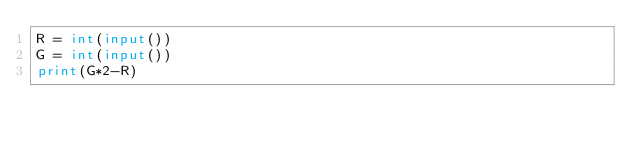<code> <loc_0><loc_0><loc_500><loc_500><_Python_>R = int(input())
G = int(input())
print(G*2-R)</code> 